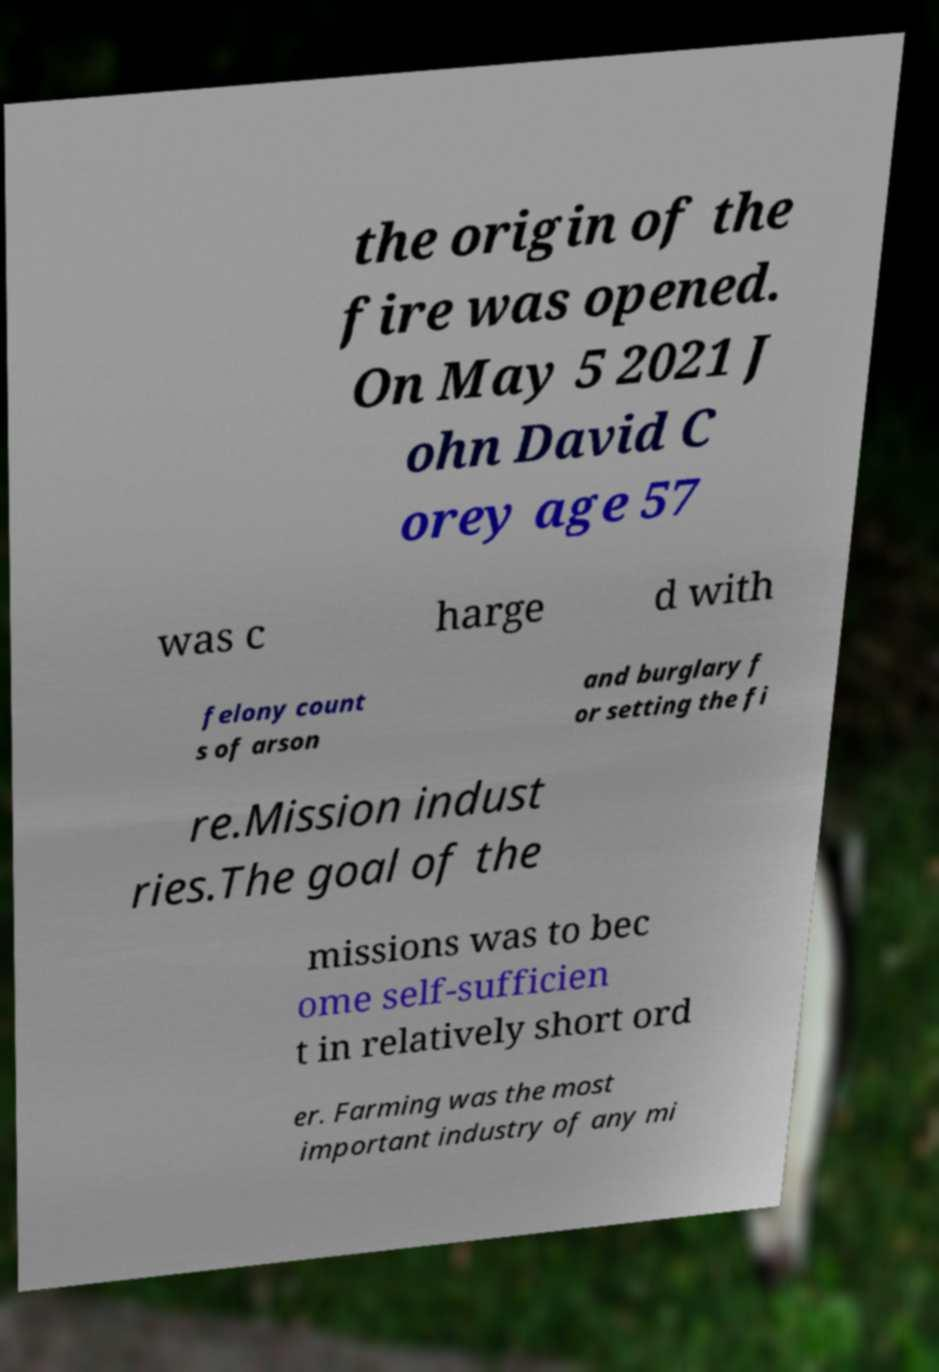Can you accurately transcribe the text from the provided image for me? the origin of the fire was opened. On May 5 2021 J ohn David C orey age 57 was c harge d with felony count s of arson and burglary f or setting the fi re.Mission indust ries.The goal of the missions was to bec ome self-sufficien t in relatively short ord er. Farming was the most important industry of any mi 